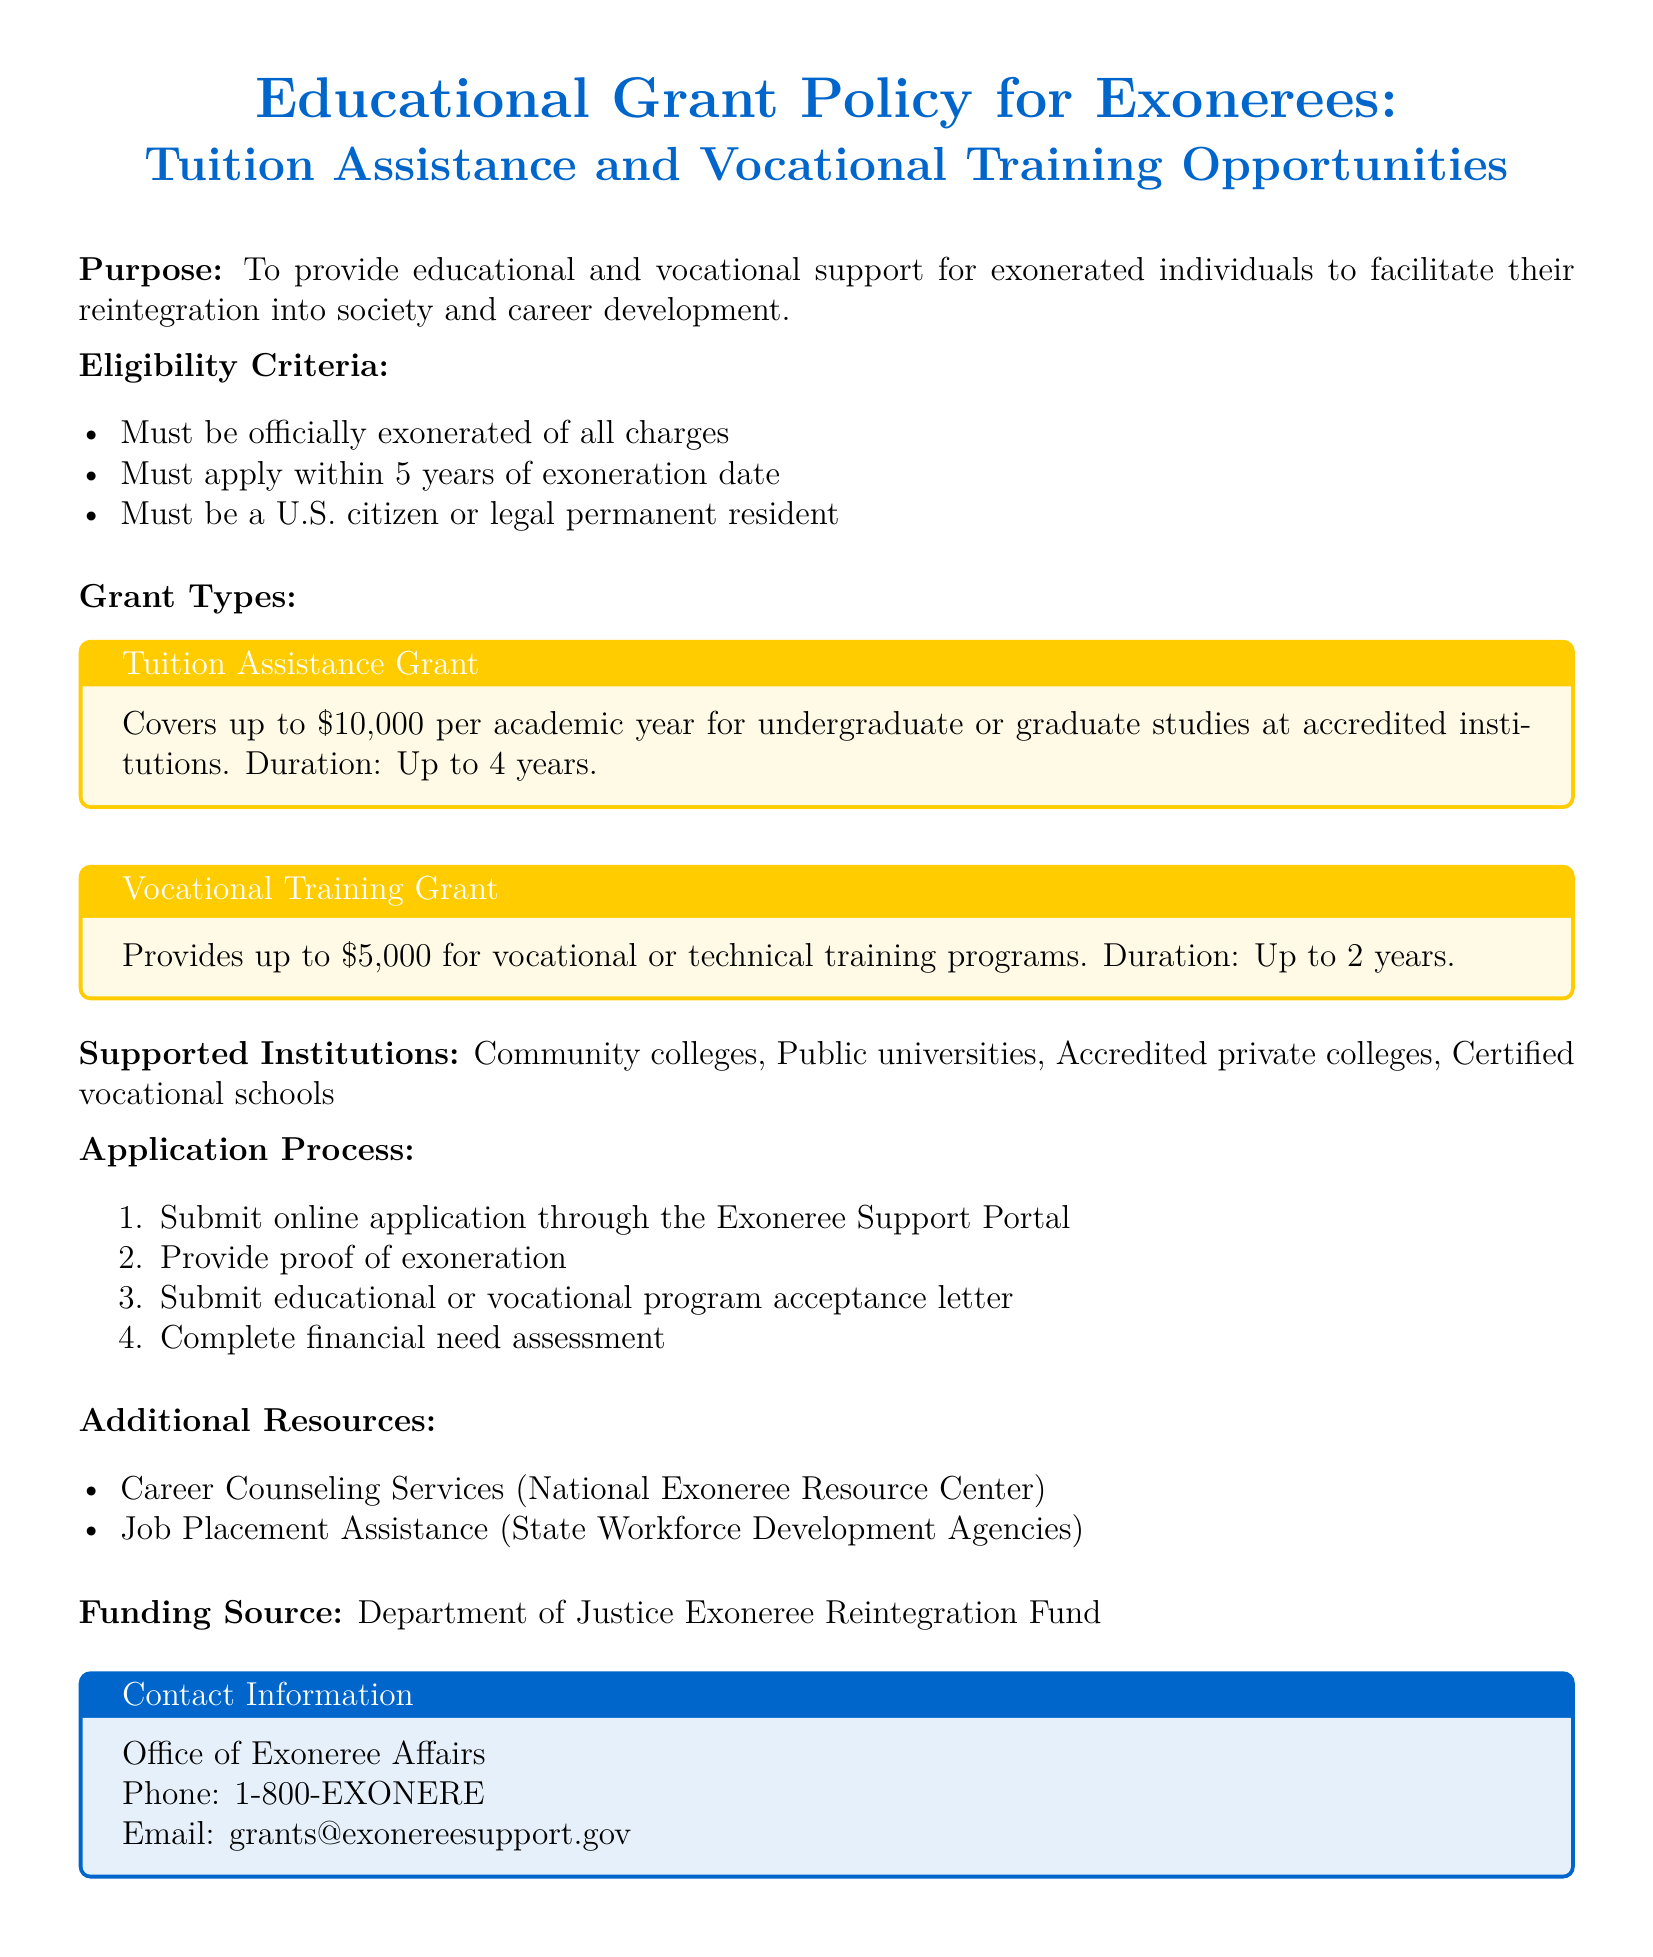What is the maximum tuition assistance grant available? The maximum tuition assistance grant is specified in the document under the Grant Types section, which states it covers up to $10,000 per academic year.
Answer: $10,000 Who provides job placement assistance? The document lists job placement assistance provided by State Workforce Development Agencies.
Answer: State Workforce Development Agencies How long can the vocational training grant last? The duration of the vocational training grant is mentioned in the Grant Types section, which states it lasts for up to 2 years.
Answer: Up to 2 years What is required to apply for the educational grants? The application process specifies that several documents must be submitted, including proof of exoneration and a program acceptance letter.
Answer: Proof of exoneration, program acceptance letter What is the funding source mentioned for the grants? The document identifies the funding source in a specific section, stating it is the Department of Justice Exoneree Reintegration Fund.
Answer: Department of Justice Exoneree Reintegration Fund What is the required citizenship status for eligibility? Eligibility criteria detail that applicants must be a U.S. citizen or legal permanent resident.
Answer: U.S. citizen or legal permanent resident What type of institutions are eligible for support? The supported institutions are enumerated in the document, listing several educational and vocational options available for grants.
Answer: Community colleges, public universities, accredited private colleges, certified vocational schools 